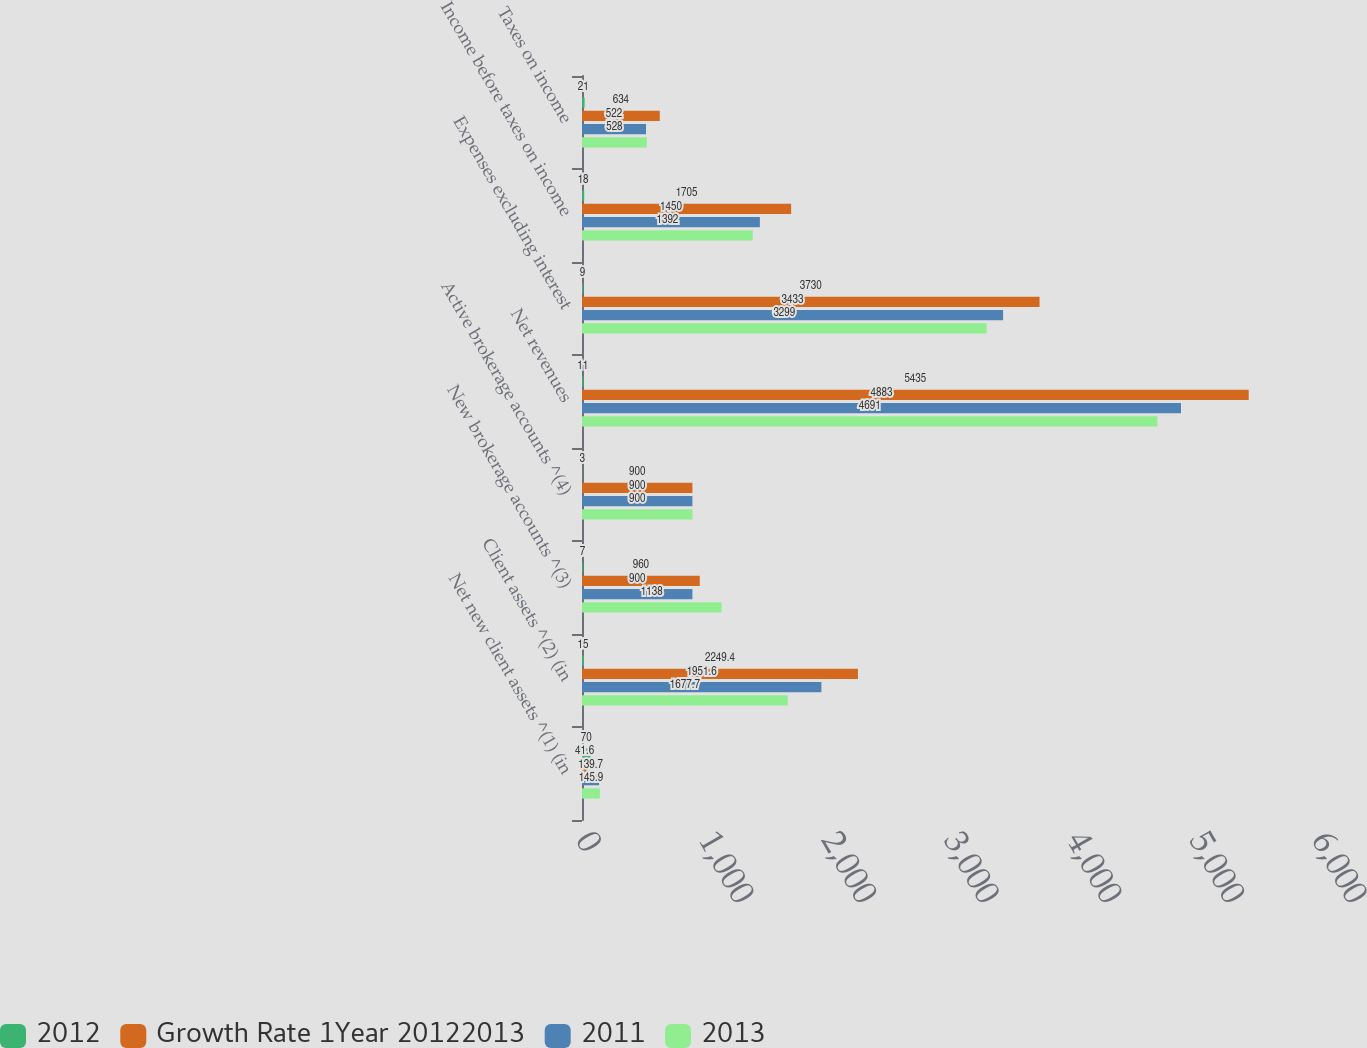Convert chart to OTSL. <chart><loc_0><loc_0><loc_500><loc_500><stacked_bar_chart><ecel><fcel>Net new client assets ^(1) (in<fcel>Client assets ^(2) (in<fcel>New brokerage accounts ^(3)<fcel>Active brokerage accounts ^(4)<fcel>Net revenues<fcel>Expenses excluding interest<fcel>Income before taxes on income<fcel>Taxes on income<nl><fcel>2012<fcel>70<fcel>15<fcel>7<fcel>3<fcel>11<fcel>9<fcel>18<fcel>21<nl><fcel>Growth Rate 1Year 20122013<fcel>41.6<fcel>2249.4<fcel>960<fcel>900<fcel>5435<fcel>3730<fcel>1705<fcel>634<nl><fcel>2011<fcel>139.7<fcel>1951.6<fcel>900<fcel>900<fcel>4883<fcel>3433<fcel>1450<fcel>522<nl><fcel>2013<fcel>145.9<fcel>1677.7<fcel>1138<fcel>900<fcel>4691<fcel>3299<fcel>1392<fcel>528<nl></chart> 